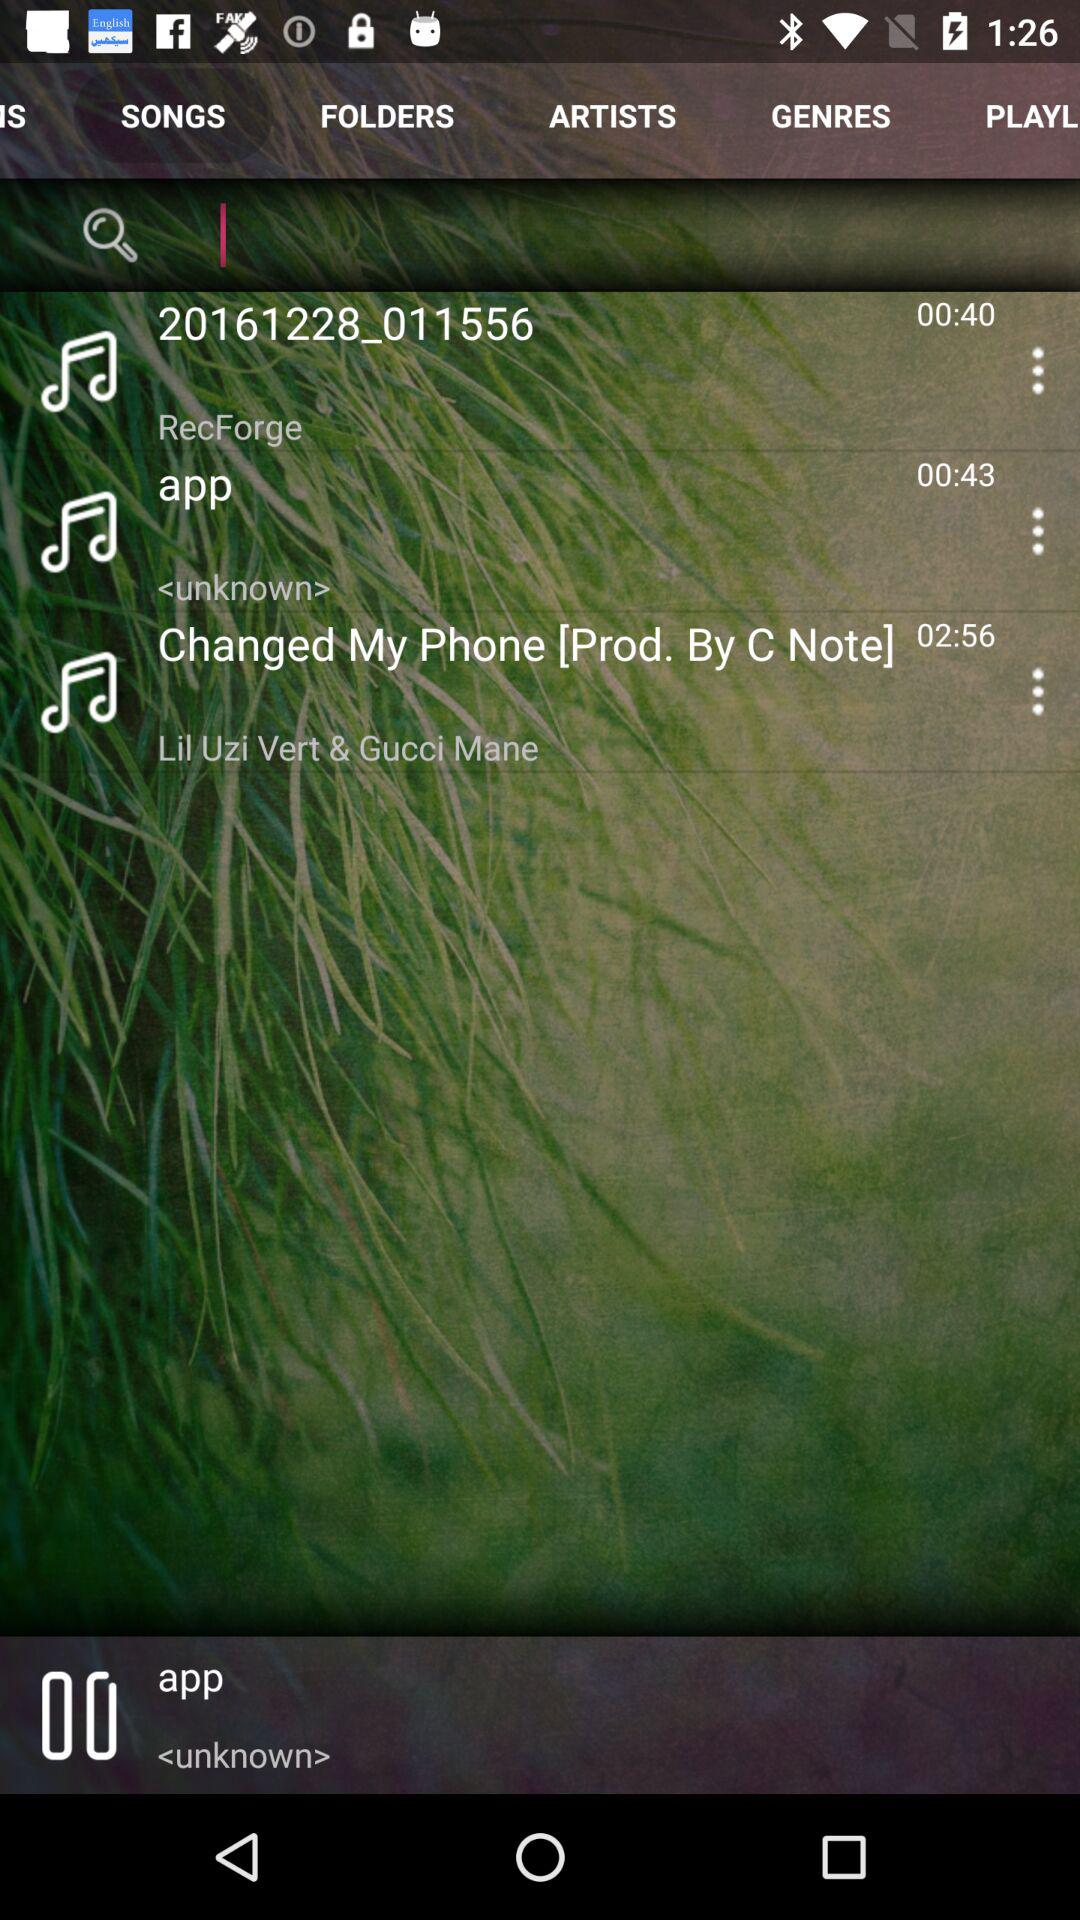How many songs are in the search results?
Answer the question using a single word or phrase. 3 